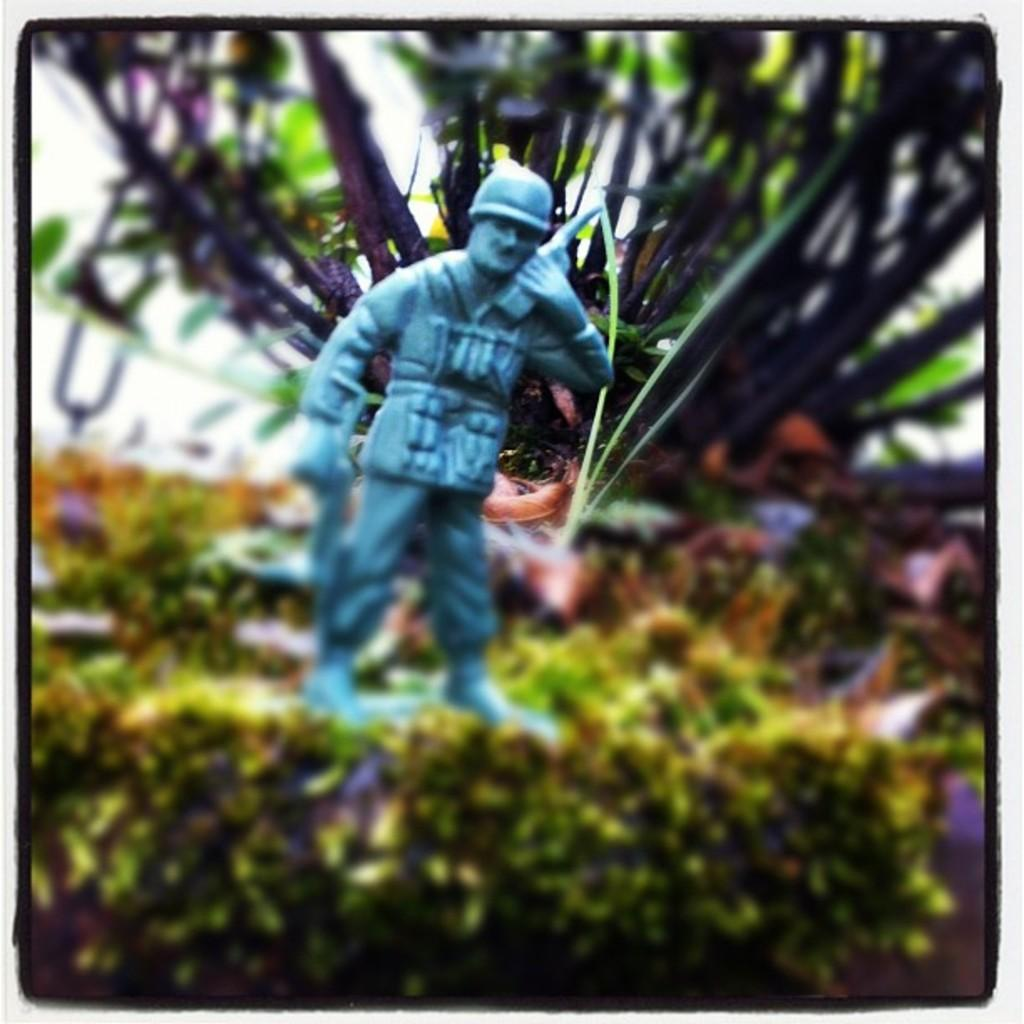What is the main subject in the image? There is a grey color statue in the image. What can be seen in the background of the image? There are trees in the background of the image. How would you describe the appearance of the background in the image? The background of the image appears blurred. What type of thrill can be experienced by the statue in the image? The statue is an inanimate object and cannot experience any thrill. How does the statue distribute its weight in the image? The statue is a solid object and does not distribute its weight in the image. 